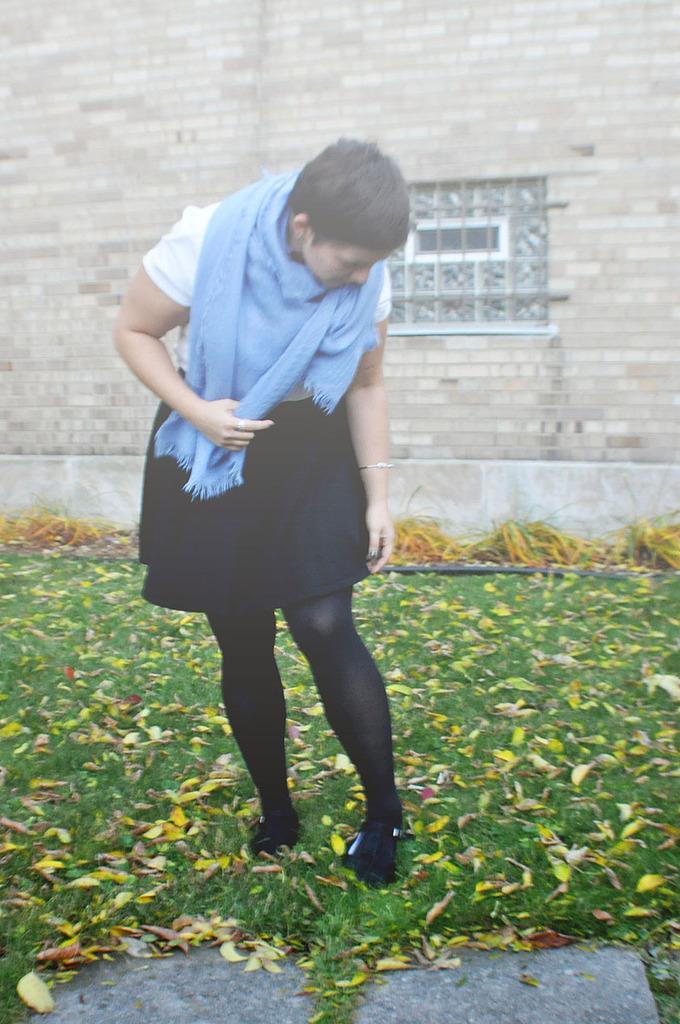Please provide a concise description of this image. In this image there is a woman standing on the grass, behind the woman there is a wall. 